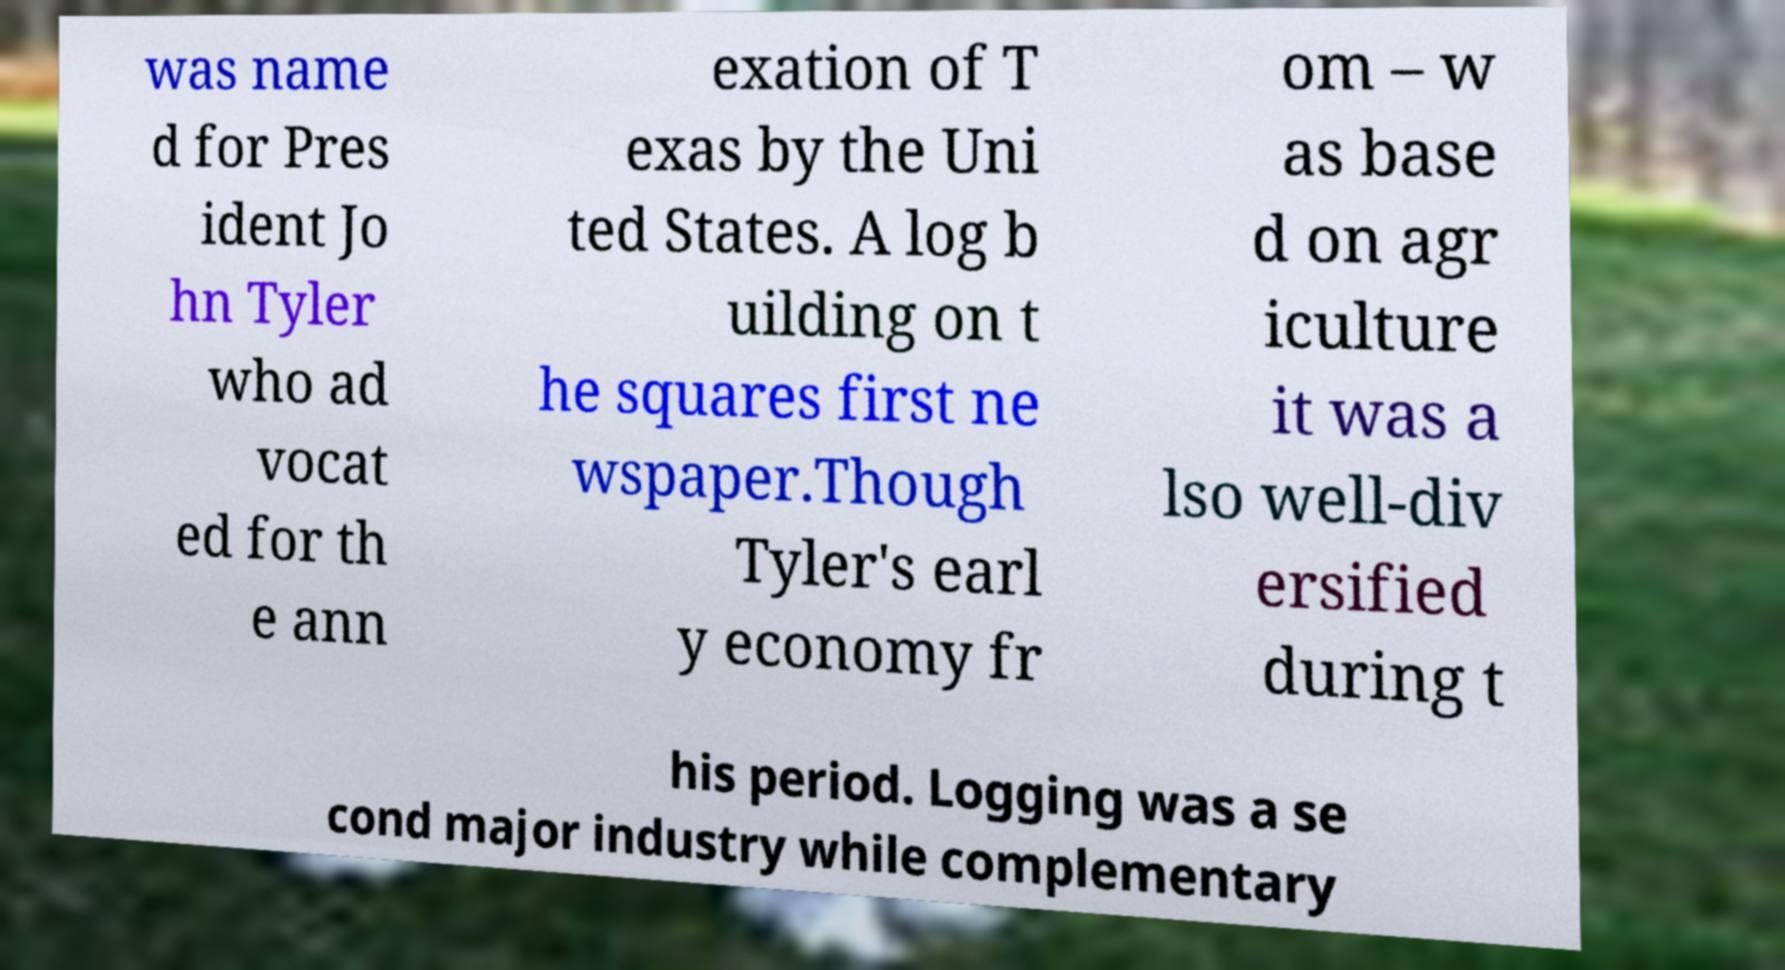Could you assist in decoding the text presented in this image and type it out clearly? was name d for Pres ident Jo hn Tyler who ad vocat ed for th e ann exation of T exas by the Uni ted States. A log b uilding on t he squares first ne wspaper.Though Tyler's earl y economy fr om – w as base d on agr iculture it was a lso well-div ersified during t his period. Logging was a se cond major industry while complementary 